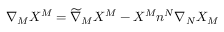Convert formula to latex. <formula><loc_0><loc_0><loc_500><loc_500>\nabla _ { M } X ^ { M } = \widetilde { \nabla } _ { M } X ^ { M } - X ^ { M } n ^ { N } \nabla _ { N } X _ { M }</formula> 